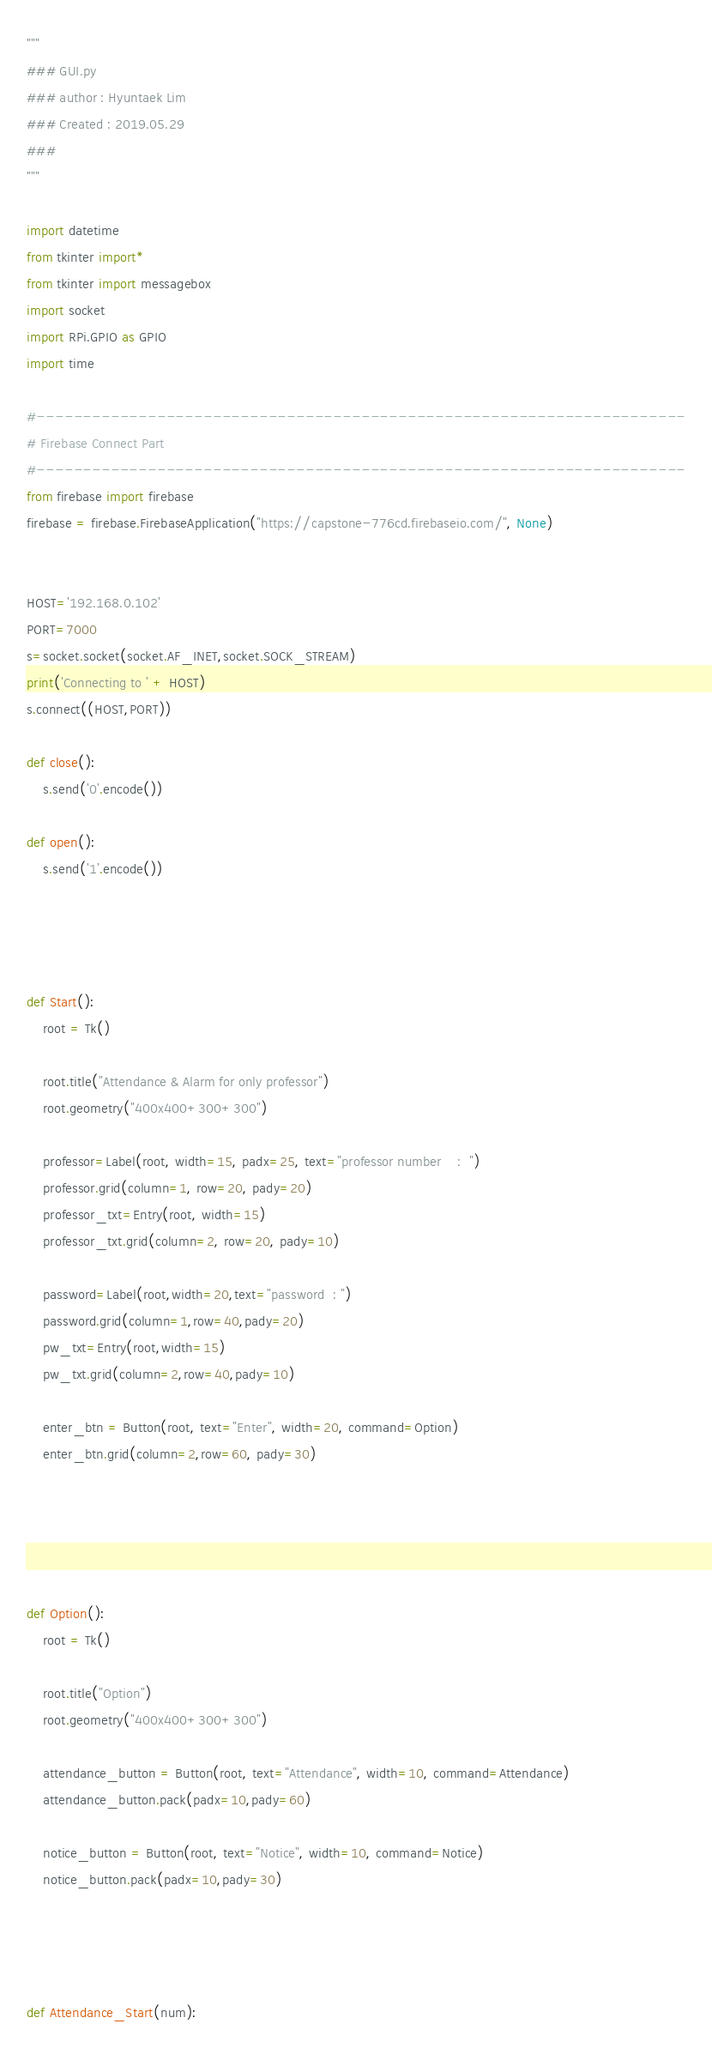Convert code to text. <code><loc_0><loc_0><loc_500><loc_500><_Python_>"""
### GUI.py
### author : Hyuntaek Lim
### Created : 2019.05.29
### 
"""

import datetime
from tkinter import*
from tkinter import messagebox
import socket
import RPi.GPIO as GPIO
import time

#----------------------------------------------------------------------
# Firebase Connect Part
#----------------------------------------------------------------------
from firebase import firebase
firebase = firebase.FirebaseApplication("https://capstone-776cd.firebaseio.com/", None)


HOST='192.168.0.102'
PORT=7000
s=socket.socket(socket.AF_INET,socket.SOCK_STREAM)
print('Connecting to ' + HOST)
s.connect((HOST,PORT))

def close():
    s.send('0'.encode())

def open():
    s.send('1'.encode())




def Start():
    root = Tk()

    root.title("Attendance & Alarm for only professor")
    root.geometry("400x400+300+300")

    professor=Label(root, width=15, padx=25, text="professor number    :  ")
    professor.grid(column=1, row=20, pady=20)
    professor_txt=Entry(root, width=15)
    professor_txt.grid(column=2, row=20, pady=10)

    password=Label(root,width=20,text="password  : ")
    password.grid(column=1,row=40,pady=20)
    pw_txt=Entry(root,width=15)
    pw_txt.grid(column=2,row=40,pady=10)

    enter_btn = Button(root, text="Enter", width=20, command=Option)
    enter_btn.grid(column=2,row=60, pady=30)





def Option():
    root = Tk()

    root.title("Option")
    root.geometry("400x400+300+300")

    attendance_button = Button(root, text="Attendance", width=10, command=Attendance)
    attendance_button.pack(padx=10,pady=60)

    notice_button = Button(root, text="Notice", width=10, command=Notice)
    notice_button.pack(padx=10,pady=30)




def Attendance_Start(num):</code> 